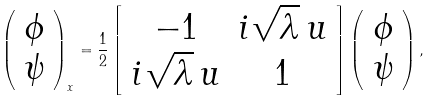Convert formula to latex. <formula><loc_0><loc_0><loc_500><loc_500>\left ( \begin{array} { c c } \phi \\ \psi \end{array} \right ) _ { x } = \frac { 1 } { 2 } \left [ \begin{array} { c c } - 1 & i \sqrt { \lambda } \, u \\ i \sqrt { \lambda } \, u & 1 \end{array} \right ] \left ( \begin{array} { c c } \phi \\ \psi \end{array} \right ) ,</formula> 